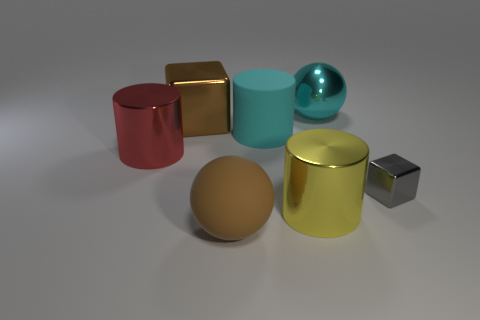Are there any brown shiny objects of the same shape as the big red object?
Offer a terse response. No. There is a brown matte thing that is the same size as the metal ball; what shape is it?
Provide a short and direct response. Sphere. What shape is the big metal thing left of the large cube?
Offer a very short reply. Cylinder. Is the number of red shiny cylinders that are to the right of the small shiny block less than the number of big red cylinders that are to the right of the cyan metallic thing?
Make the answer very short. No. There is a red thing; is it the same size as the block on the left side of the cyan cylinder?
Your answer should be very brief. Yes. How many gray objects are the same size as the rubber cylinder?
Offer a terse response. 0. There is a small block that is the same material as the big cyan sphere; what is its color?
Offer a very short reply. Gray. Is the number of small shiny balls greater than the number of big cyan cylinders?
Your response must be concise. No. Is the material of the large block the same as the brown ball?
Your response must be concise. No. There is another cyan object that is the same material as the tiny object; what is its shape?
Your response must be concise. Sphere. 